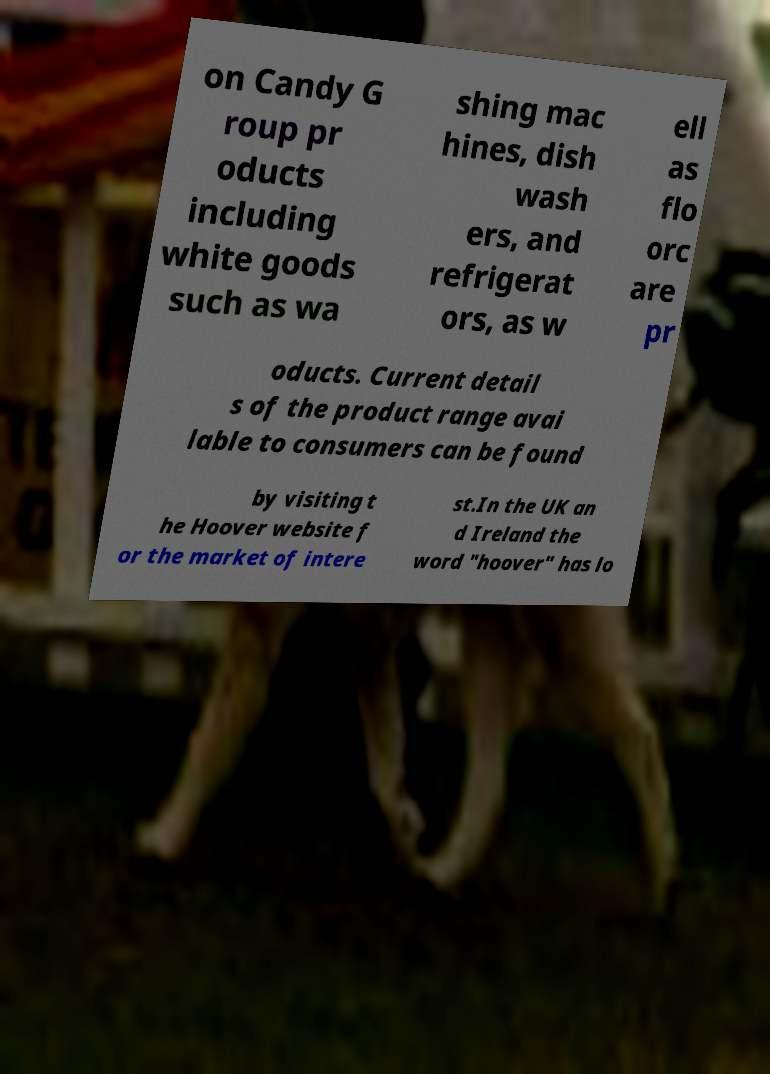What messages or text are displayed in this image? I need them in a readable, typed format. on Candy G roup pr oducts including white goods such as wa shing mac hines, dish wash ers, and refrigerat ors, as w ell as flo orc are pr oducts. Current detail s of the product range avai lable to consumers can be found by visiting t he Hoover website f or the market of intere st.In the UK an d Ireland the word "hoover" has lo 